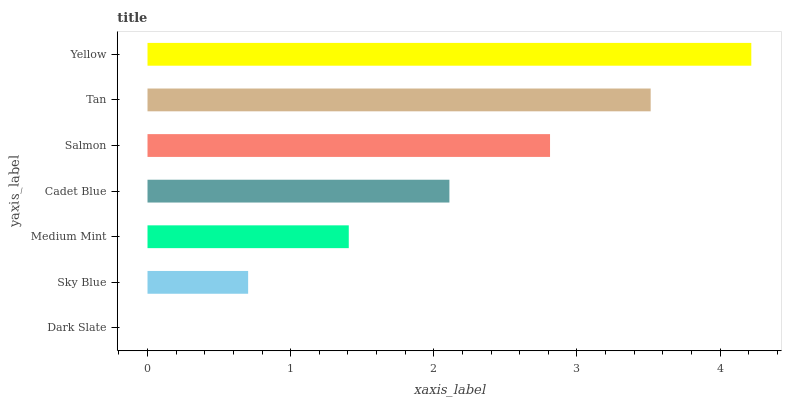Is Dark Slate the minimum?
Answer yes or no. Yes. Is Yellow the maximum?
Answer yes or no. Yes. Is Sky Blue the minimum?
Answer yes or no. No. Is Sky Blue the maximum?
Answer yes or no. No. Is Sky Blue greater than Dark Slate?
Answer yes or no. Yes. Is Dark Slate less than Sky Blue?
Answer yes or no. Yes. Is Dark Slate greater than Sky Blue?
Answer yes or no. No. Is Sky Blue less than Dark Slate?
Answer yes or no. No. Is Cadet Blue the high median?
Answer yes or no. Yes. Is Cadet Blue the low median?
Answer yes or no. Yes. Is Yellow the high median?
Answer yes or no. No. Is Tan the low median?
Answer yes or no. No. 